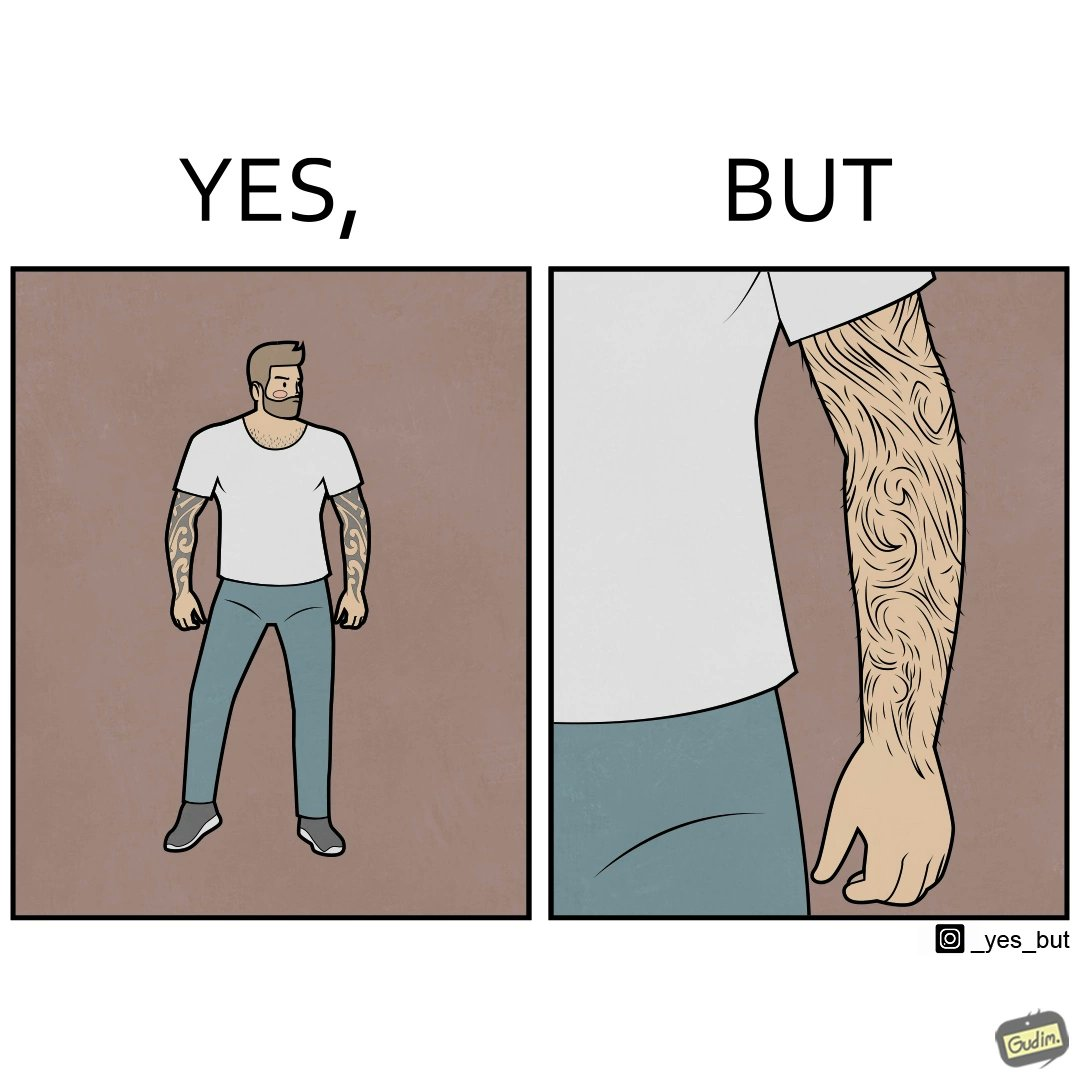What does this image depict? The image is funny because while from the distance it seems that the man has big tattoos on both of his arms upon a closer look at the arms it turns out there is no tattoo and what seemed to be tattoos are just hairs on his arm. 